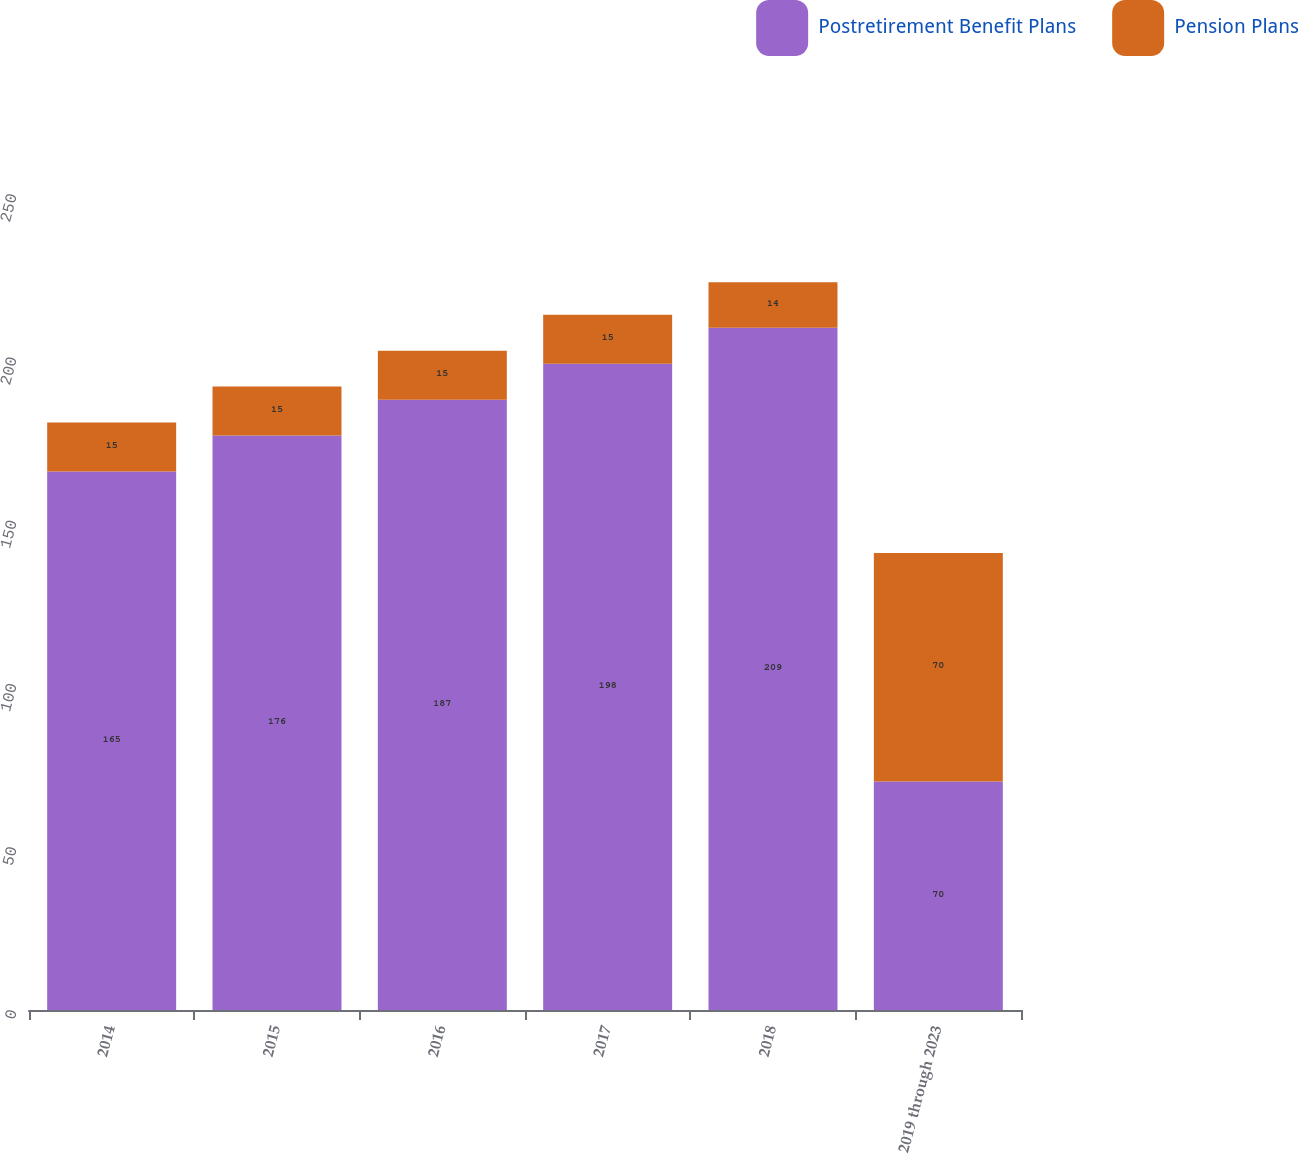Convert chart. <chart><loc_0><loc_0><loc_500><loc_500><stacked_bar_chart><ecel><fcel>2014<fcel>2015<fcel>2016<fcel>2017<fcel>2018<fcel>2019 through 2023<nl><fcel>Postretirement Benefit Plans<fcel>165<fcel>176<fcel>187<fcel>198<fcel>209<fcel>70<nl><fcel>Pension Plans<fcel>15<fcel>15<fcel>15<fcel>15<fcel>14<fcel>70<nl></chart> 